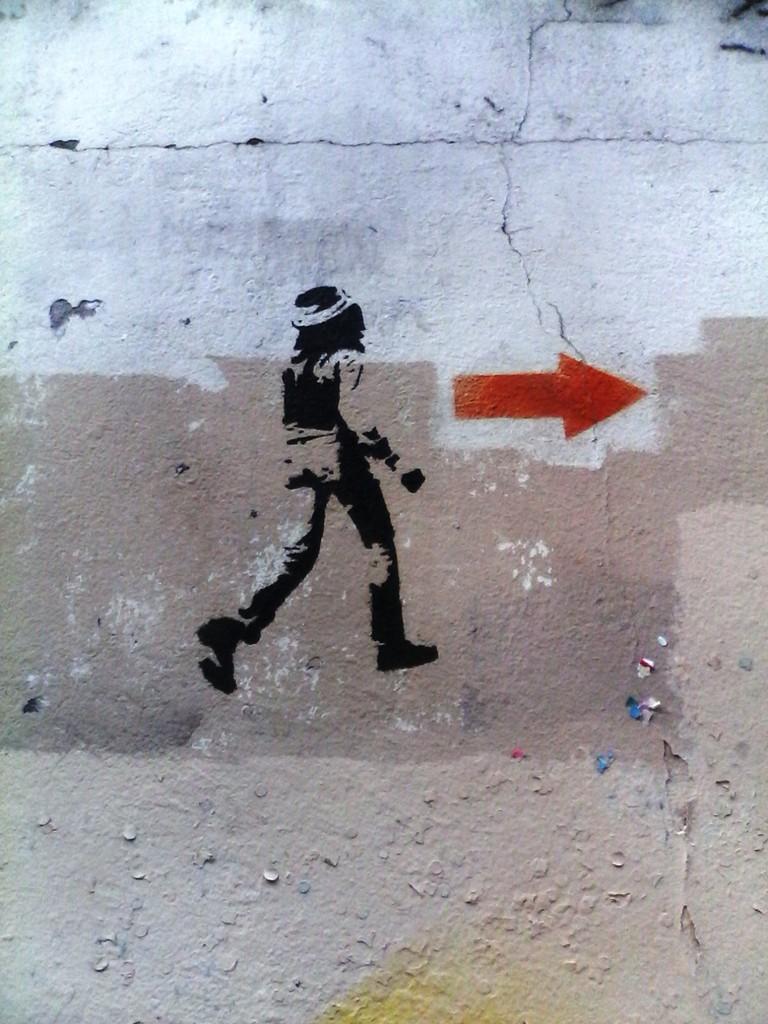Please provide a concise description of this image. In this picture we can see a small painting of a man on the white wall. Beside we can see the red arrow mark. 